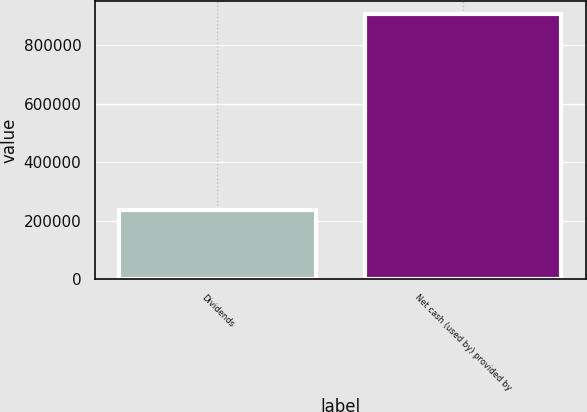<chart> <loc_0><loc_0><loc_500><loc_500><bar_chart><fcel>Dividends<fcel>Net cash (used by) provided by<nl><fcel>238300<fcel>907577<nl></chart> 